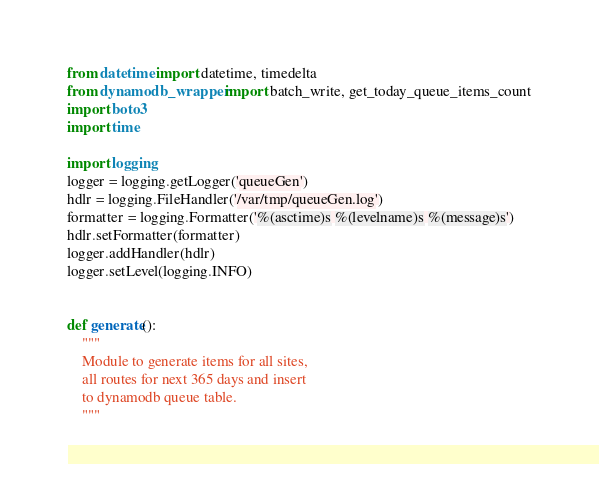Convert code to text. <code><loc_0><loc_0><loc_500><loc_500><_Python_>from datetime import datetime, timedelta
from dynamodb_wrapper import batch_write, get_today_queue_items_count
import boto3
import time

import logging
logger = logging.getLogger('queueGen')
hdlr = logging.FileHandler('/var/tmp/queueGen.log')
formatter = logging.Formatter('%(asctime)s %(levelname)s %(message)s')
hdlr.setFormatter(formatter)
logger.addHandler(hdlr)
logger.setLevel(logging.INFO)


def generate():
    """
    Module to generate items for all sites,
    all routes for next 365 days and insert
    to dynamodb queue table.
    """</code> 